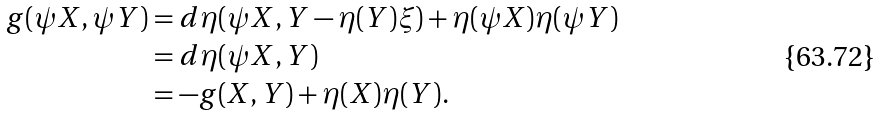<formula> <loc_0><loc_0><loc_500><loc_500>g ( \psi X , \psi Y ) & = d \eta ( \psi X , Y - \eta ( Y ) \xi ) + \eta ( \psi X ) \eta ( \psi Y ) \\ & = d \eta ( \psi X , Y ) \\ & = - g ( X , Y ) + \eta ( X ) \eta ( Y ) .</formula> 